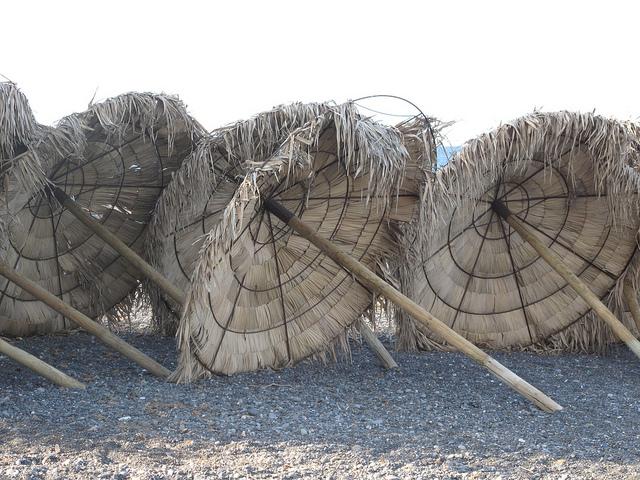Could this be in the beach?
Short answer required. Yes. How many umbrellas  are these?
Keep it brief. 6. What are the poles made out of?
Answer briefly. Wood. 